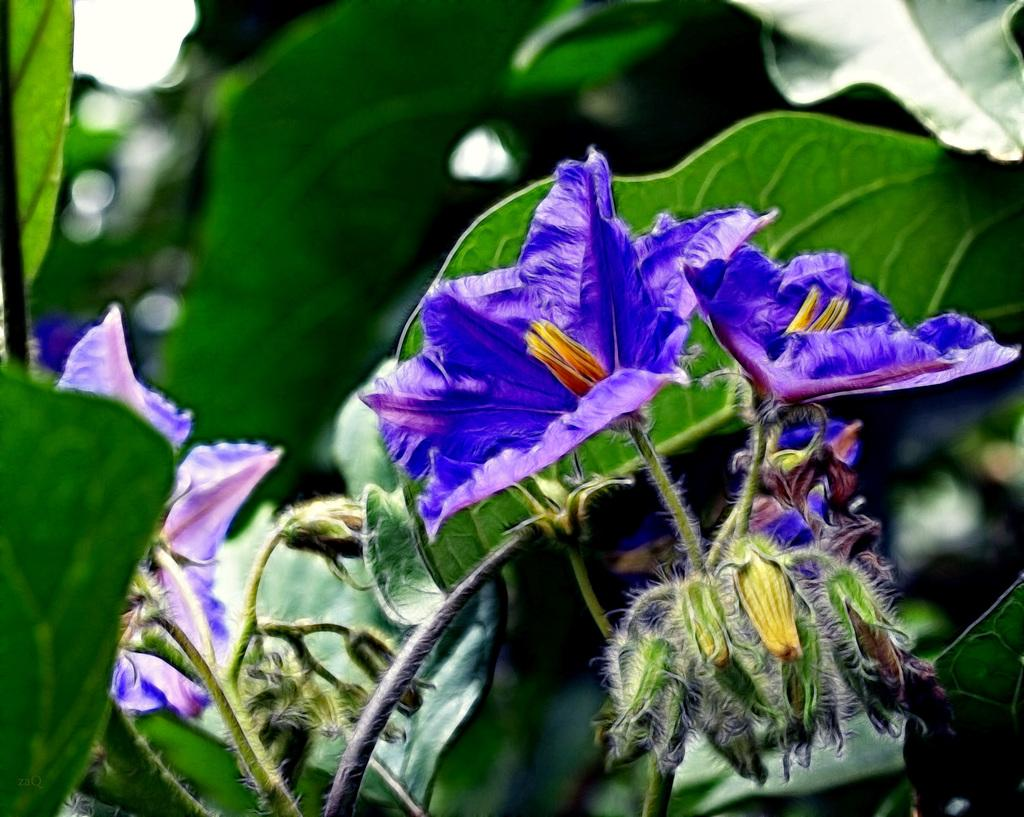What type of living organisms can be seen in the image? There are flowers on plants in the image. Can you describe the plants in the image? The plants in the image have flowers on them. What is the name of the mom in the image? There is no mom present in the image, as it only features flowers on plants. 